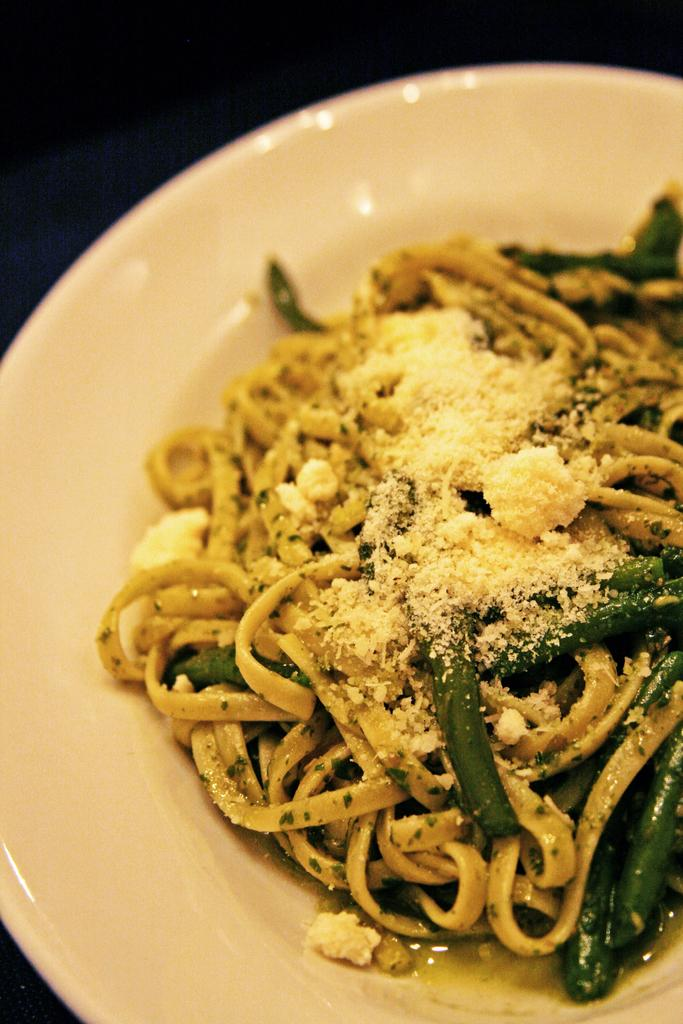What is on the plate that is visible in the image? There are noodles and cut vegetables on the plate. What color is the plate in the image? The plate is white in color. What is the plate placed on in the image? The plate is placed on a dark surface. What type of finger can be seen touching the texture of the noodles in the image? There are no fingers or texture of the noodles visible in the image. 